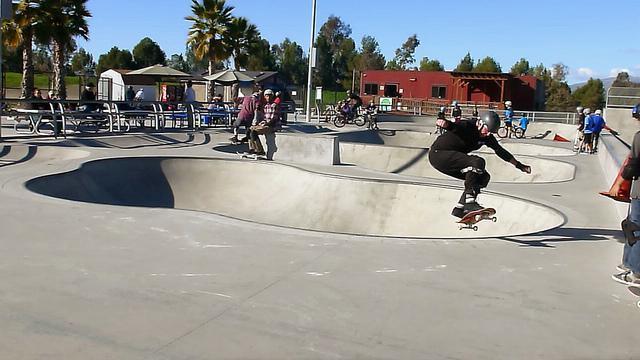How many people are in mid-air in the photo?
Give a very brief answer. 1. How many windows are on the red building in the background?
Give a very brief answer. 3. How many people are in the picture?
Give a very brief answer. 3. How many zebras are on the road?
Give a very brief answer. 0. 